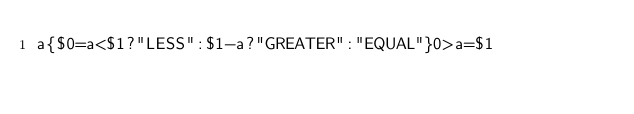<code> <loc_0><loc_0><loc_500><loc_500><_Awk_>a{$0=a<$1?"LESS":$1-a?"GREATER":"EQUAL"}0>a=$1</code> 